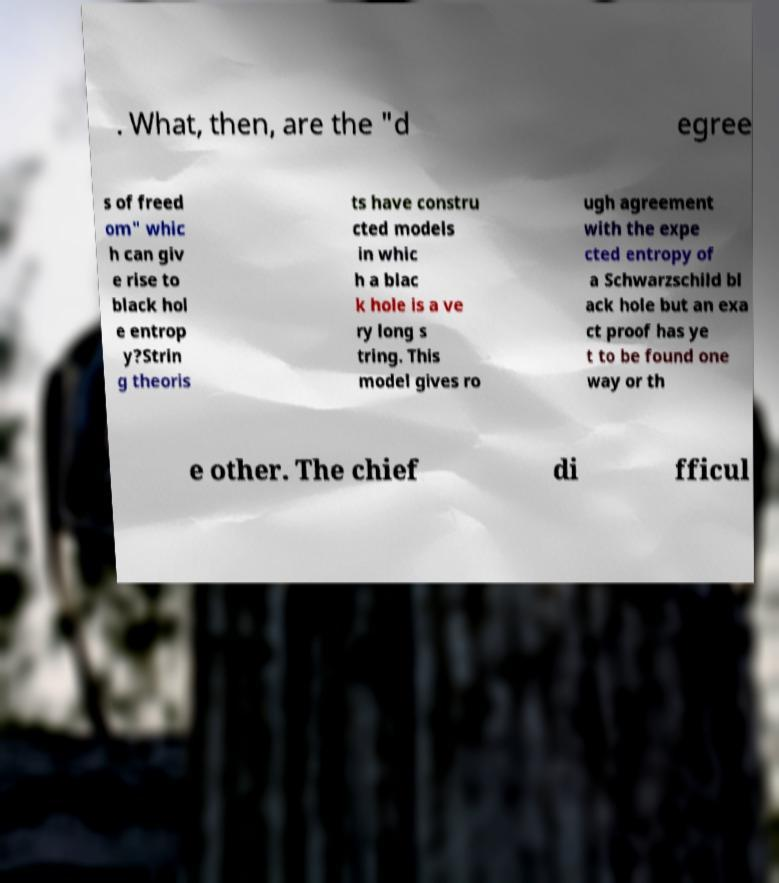I need the written content from this picture converted into text. Can you do that? . What, then, are the "d egree s of freed om" whic h can giv e rise to black hol e entrop y?Strin g theoris ts have constru cted models in whic h a blac k hole is a ve ry long s tring. This model gives ro ugh agreement with the expe cted entropy of a Schwarzschild bl ack hole but an exa ct proof has ye t to be found one way or th e other. The chief di fficul 